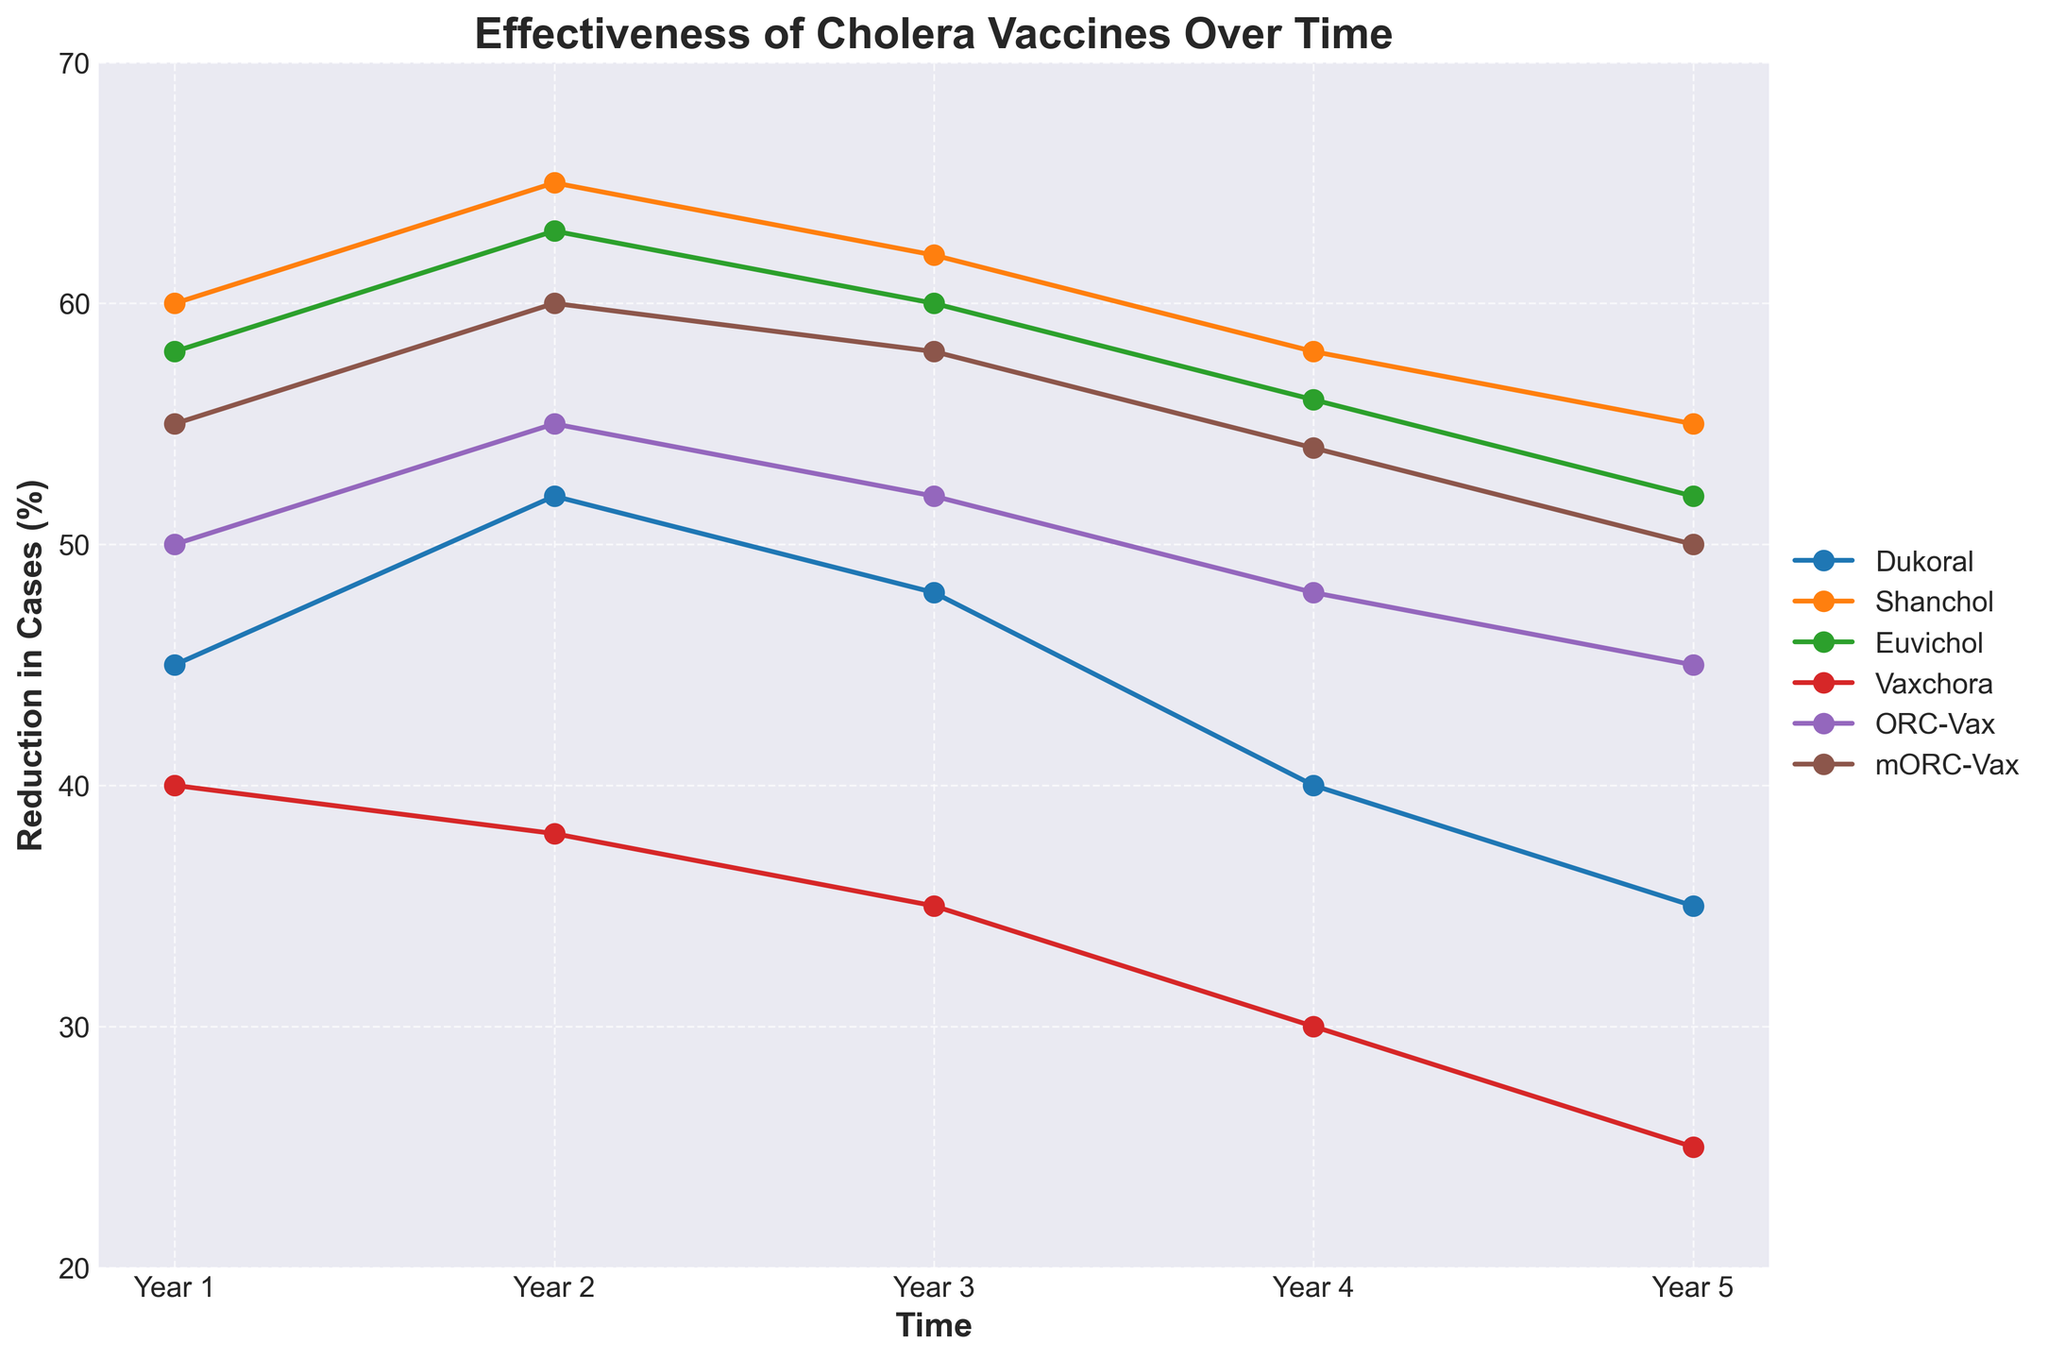Which vaccine shows the highest reduction in cholera cases in Year 5? Observe the point on the y-axis in Year 5 for each vaccine and identify the one with the highest value. Dukeoral has 35, Shanchol has 55, Euvichol has 52, Vaxchora has 25, ORC-Vax has 45, and mORC-Vax has 50. Shanchol has the highest reduction.
Answer: Shanchol How does the reduction in cholera cases for Vaxchora change from Year 1 to Year 5? Look at the endpoints for Vaxchora in Year 1 and Year 5 on the y-axis. In Year 1, it is at 40, and in Year 5, it is at 25. Calculate the difference: 40 - 25.
Answer: 15 Which vaccine shows an increase in effectiveness in the second year compared to the first year? Compare the value between Year 1 and Year 2 for each vaccine. Dukoral increases from 45 to 52, Shanchol from 60 to 65, Euvichol from 58 to 63, Vaxchora decreases from 40 to 38, ORC-Vax from 50 to 55, and mORC-Vax from 55 to 60.
Answer: All but Vaxchora Which vaccines have a reduction in effectiveness from Year 2 to Year 3? Compare the values for Year 2 and Year 3 for each vaccine. Dukoral goes from 52 to 48, Shanchol from 65 to 62, Euvichol from 63 to 60, Vaxchora from 38 to 35, ORC-Vax from 55 to 52, mORC-Vax from 60 to 58. All vaccines show a reduction.
Answer: All vaccines What is the average reduction in cases for ORC-Vax over the five years? Sum the values for ORC-Vax over the five years: 50, 55, 52, 48, 45. Calculate the average: (50 + 55 + 52 + 48 + 45) / 5 = 50.
Answer: 50 What is the total reduction in cholera cases for Dukoral in Years 3, 4, and 5? Sum the values for Dukoral in Year 3, Year 4, and Year 5: 48, 40, 35. Total reduction = 48 + 40 + 35.
Answer: 123 